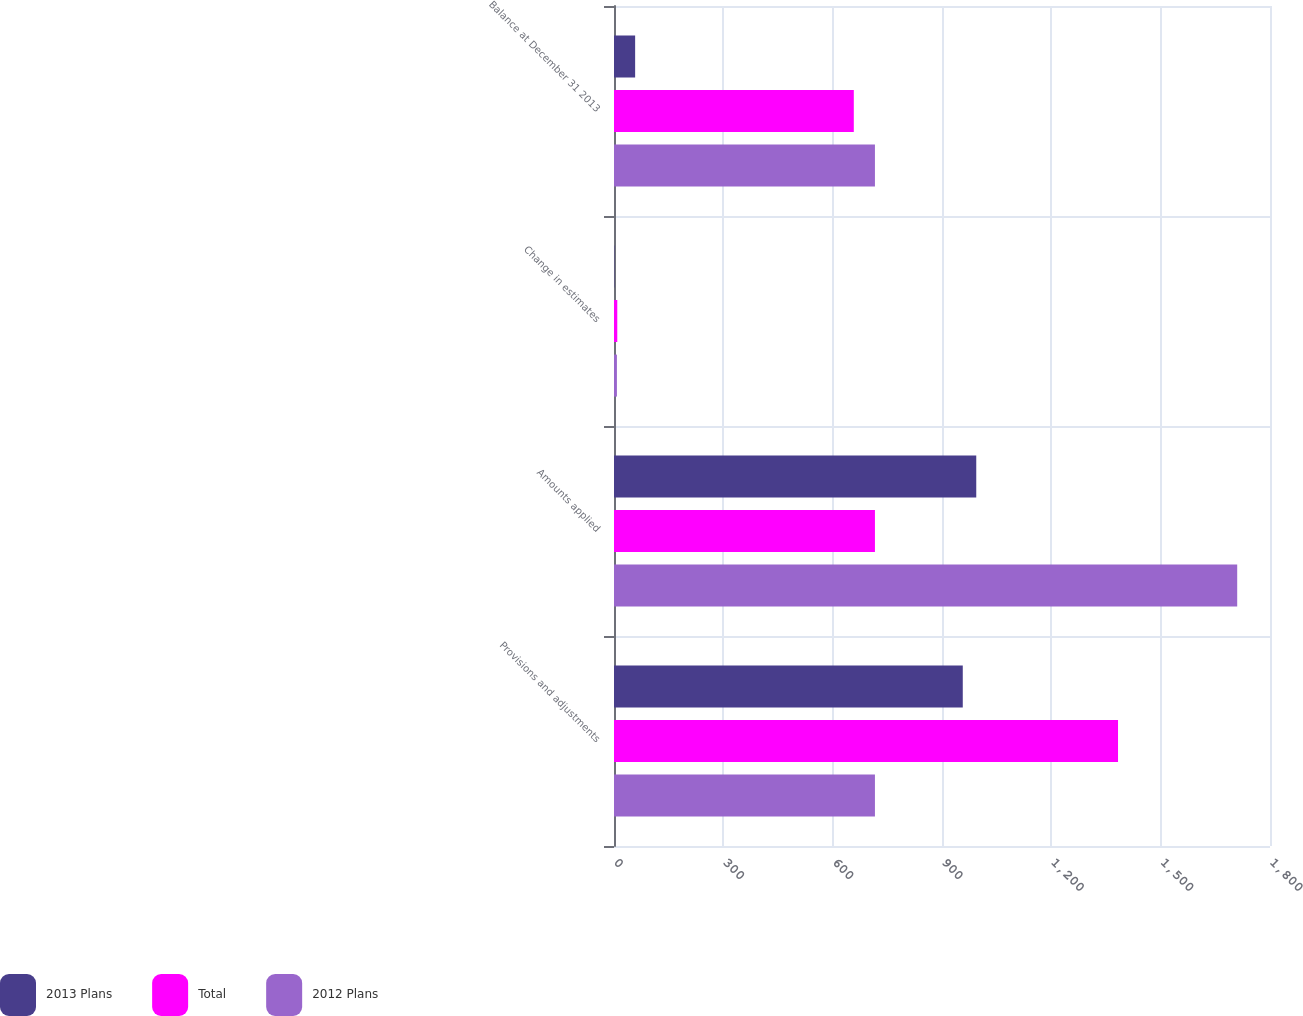Convert chart. <chart><loc_0><loc_0><loc_500><loc_500><stacked_bar_chart><ecel><fcel>Provisions and adjustments<fcel>Amounts applied<fcel>Change in estimates<fcel>Balance at December 31 2013<nl><fcel>2013 Plans<fcel>957<fcel>994<fcel>1<fcel>58<nl><fcel>Total<fcel>1383<fcel>716<fcel>9<fcel>658<nl><fcel>2012 Plans<fcel>716<fcel>1710<fcel>8<fcel>716<nl></chart> 